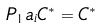Convert formula to latex. <formula><loc_0><loc_0><loc_500><loc_500>P _ { 1 } a _ { i } C ^ { * } = C ^ { * }</formula> 